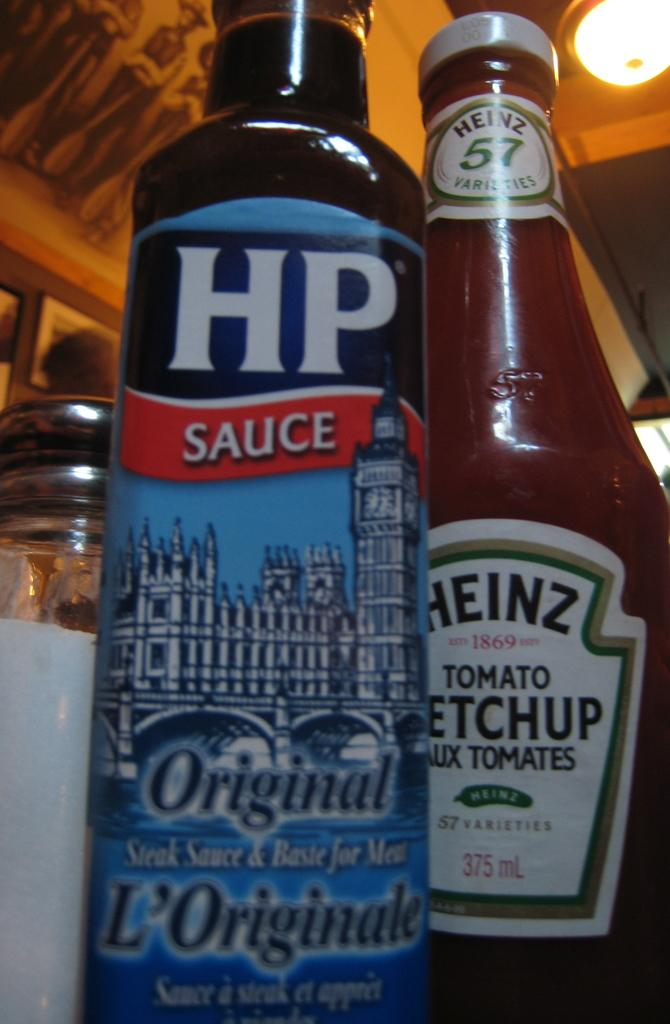How many bottles are visible in the image? There are two bottles in the image. Where are the bottles located? The bottles are on a table. What type of tax is being discussed in the image? There is no discussion of tax in the image; it only features two bottles on a table. 